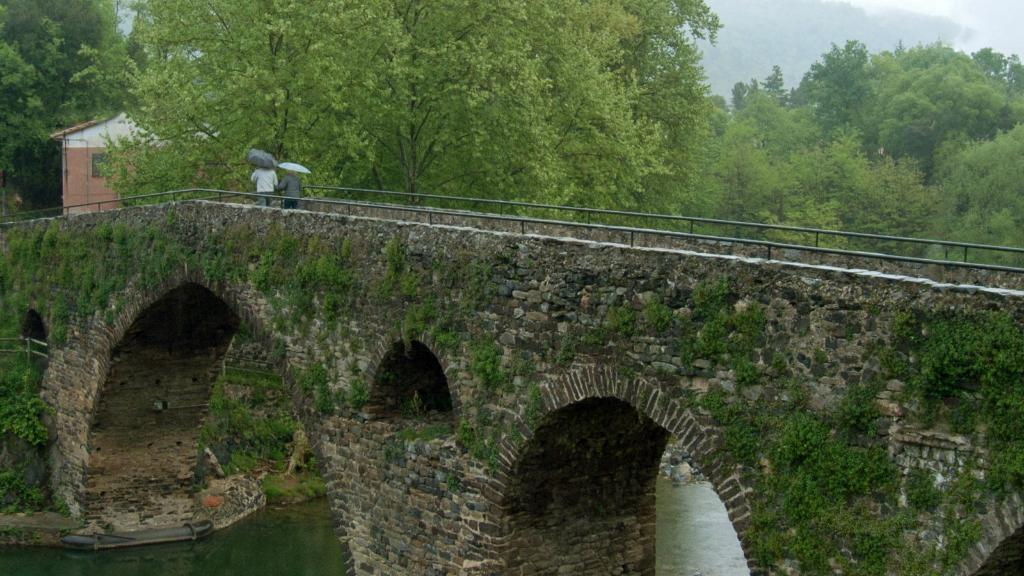What type of natural elements can be seen in the image? There are trees and water visible in the image. What can be seen in the sky in the image? The sky is visible in the image. What type of man-made structures are present in the image? There are buildings and a bridge in the image. What are the two persons in the image doing? The two persons are walking on the bridge. What are the persons holding while walking on the bridge? The persons are holding umbrellas. What type of cushion can be seen on the bridge in the image? There is no cushion present on the bridge in the image. What type of songs can be heard coming from the buildings in the image? There is no indication of any sounds or songs coming from the buildings in the image. 